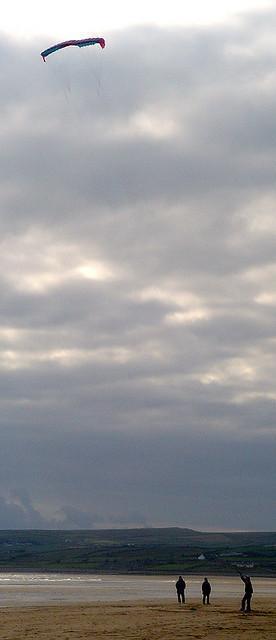How many people are in this picture?
Give a very brief answer. 3. 